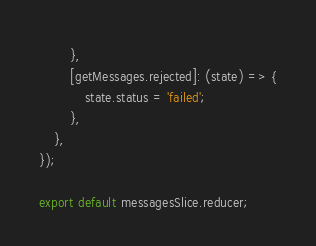<code> <loc_0><loc_0><loc_500><loc_500><_JavaScript_>        },
        [getMessages.rejected]: (state) => {
            state.status = 'failed';
        },
    },
});

export default messagesSlice.reducer;</code> 